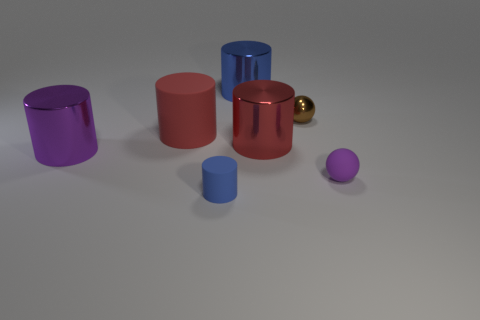Does the large purple object have the same shape as the tiny purple object?
Ensure brevity in your answer.  No. What is the size of the cylinder that is the same color as the small matte sphere?
Offer a very short reply. Large. There is a blue thing in front of the large purple thing; what number of tiny purple matte spheres are in front of it?
Your answer should be very brief. 0. What number of small objects are in front of the tiny brown thing and behind the blue rubber object?
Your response must be concise. 1. What number of objects are either small blue objects or blue objects in front of the tiny brown metal sphere?
Your answer should be very brief. 1. There is another cylinder that is made of the same material as the tiny blue cylinder; what size is it?
Ensure brevity in your answer.  Large. What is the shape of the object that is to the left of the rubber cylinder that is behind the large purple cylinder?
Your response must be concise. Cylinder. How many blue objects are small cubes or matte cylinders?
Offer a very short reply. 1. Are there any purple cylinders in front of the blue cylinder that is in front of the red cylinder right of the large blue metallic cylinder?
Offer a terse response. No. The big shiny thing that is the same color as the tiny rubber ball is what shape?
Your answer should be very brief. Cylinder. 